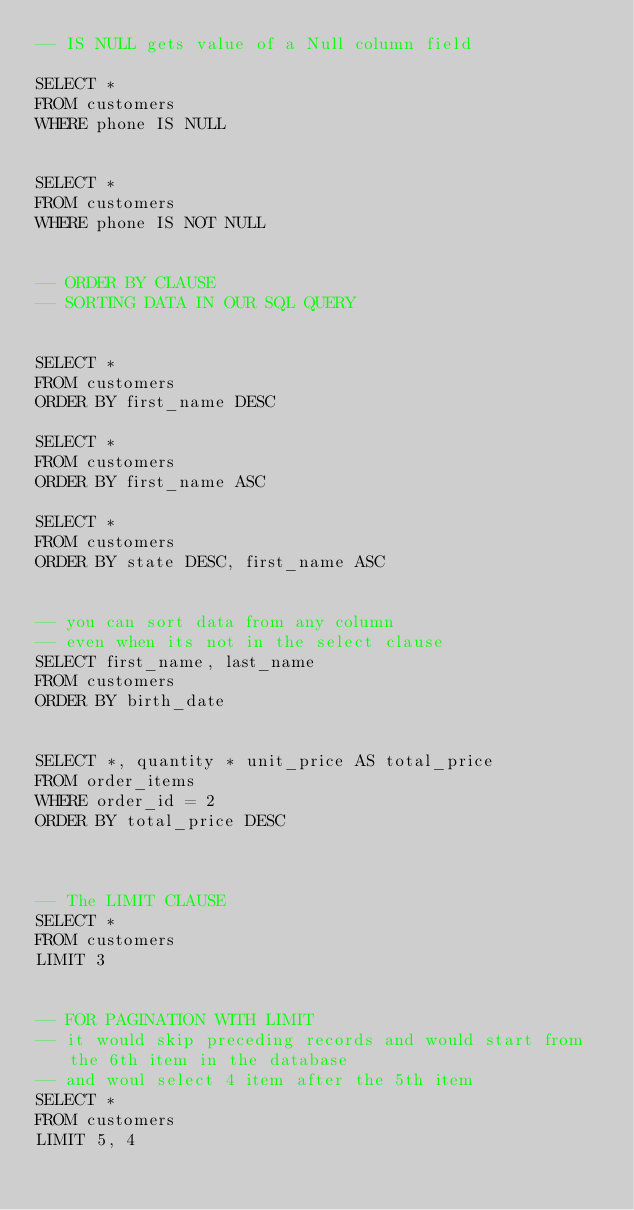<code> <loc_0><loc_0><loc_500><loc_500><_SQL_>-- IS NULL gets value of a Null column field

SELECT * 
FROM customers
WHERE phone IS NULL


SELECT * 
FROM customers
WHERE phone IS NOT NULL


-- ORDER BY CLAUSE
-- SORTING DATA IN OUR SQL QUERY


SELECT *
FROM customers
ORDER BY first_name DESC

SELECT *
FROM customers
ORDER BY first_name ASC

SELECT *
FROM customers
ORDER BY state DESC, first_name ASC


-- you can sort data from any column 
-- even when its not in the select clause
SELECT first_name, last_name
FROM customers
ORDER BY birth_date


SELECT *, quantity * unit_price AS total_price
FROM order_items
WHERE order_id = 2
ORDER BY total_price DESC



-- The LIMIT CLAUSE
SELECT *
FROM customers
LIMIT 3


-- FOR PAGINATION WITH LIMIT
-- it would skip preceding records and would start from the 6th item in the database 
-- and woul select 4 item after the 5th item
SELECT *
FROM customers
LIMIT 5, 4








</code> 